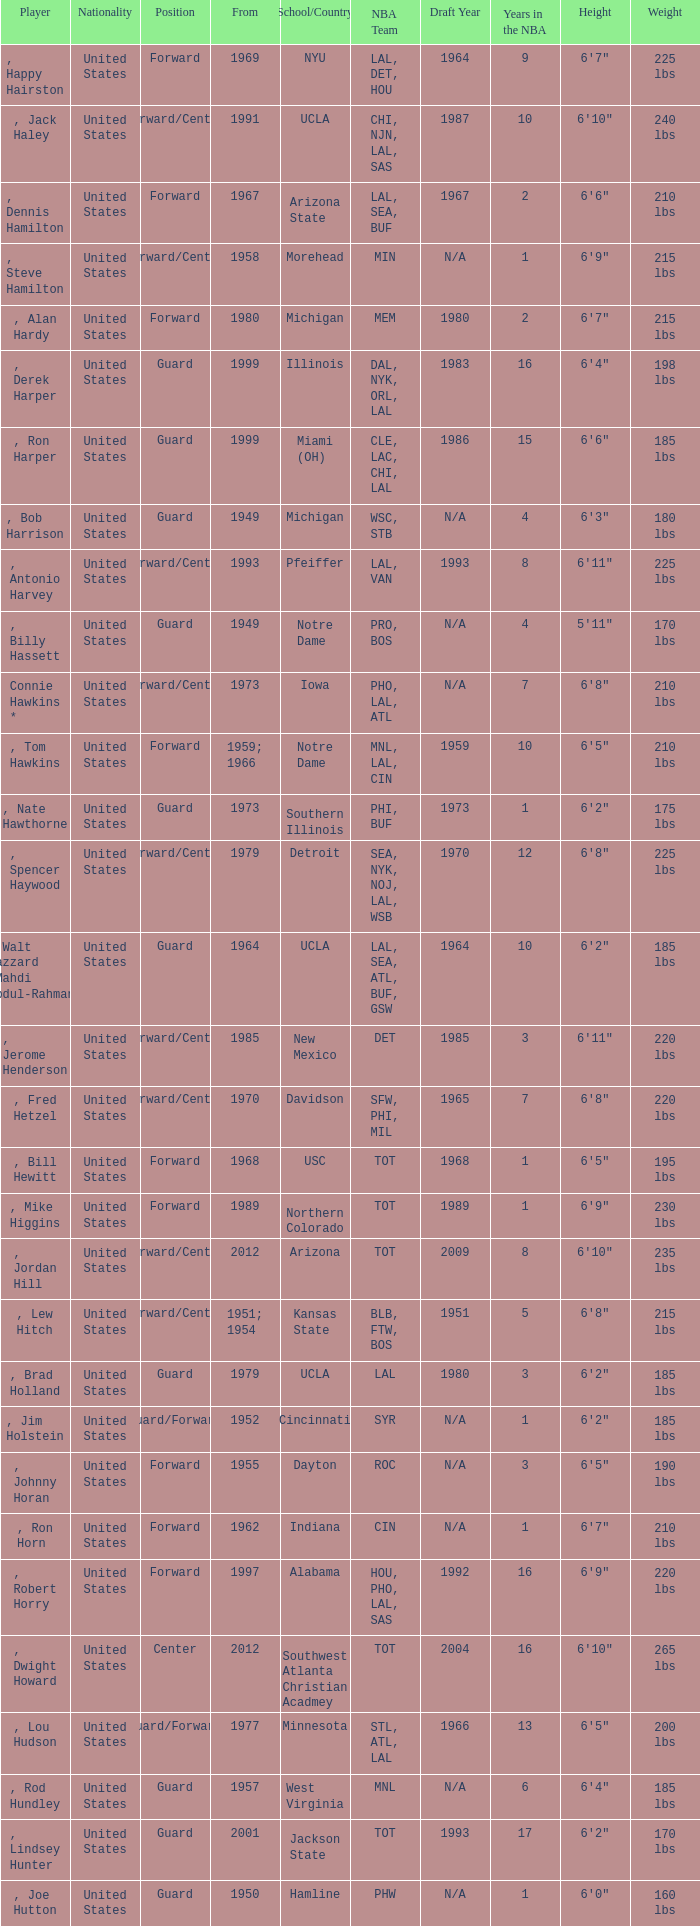Which player started in 2001? , Lindsey Hunter. 